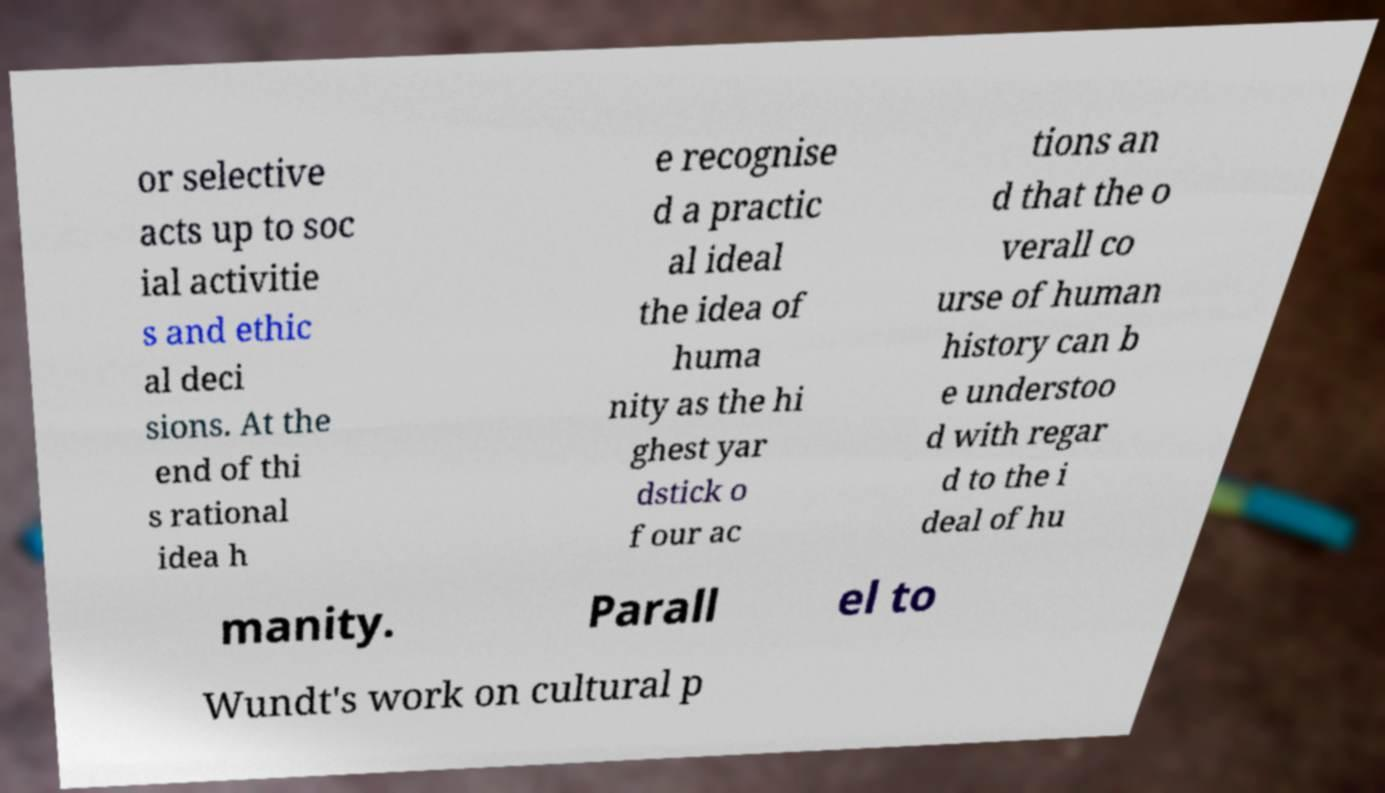Could you extract and type out the text from this image? or selective acts up to soc ial activitie s and ethic al deci sions. At the end of thi s rational idea h e recognise d a practic al ideal the idea of huma nity as the hi ghest yar dstick o f our ac tions an d that the o verall co urse of human history can b e understoo d with regar d to the i deal of hu manity. Parall el to Wundt's work on cultural p 